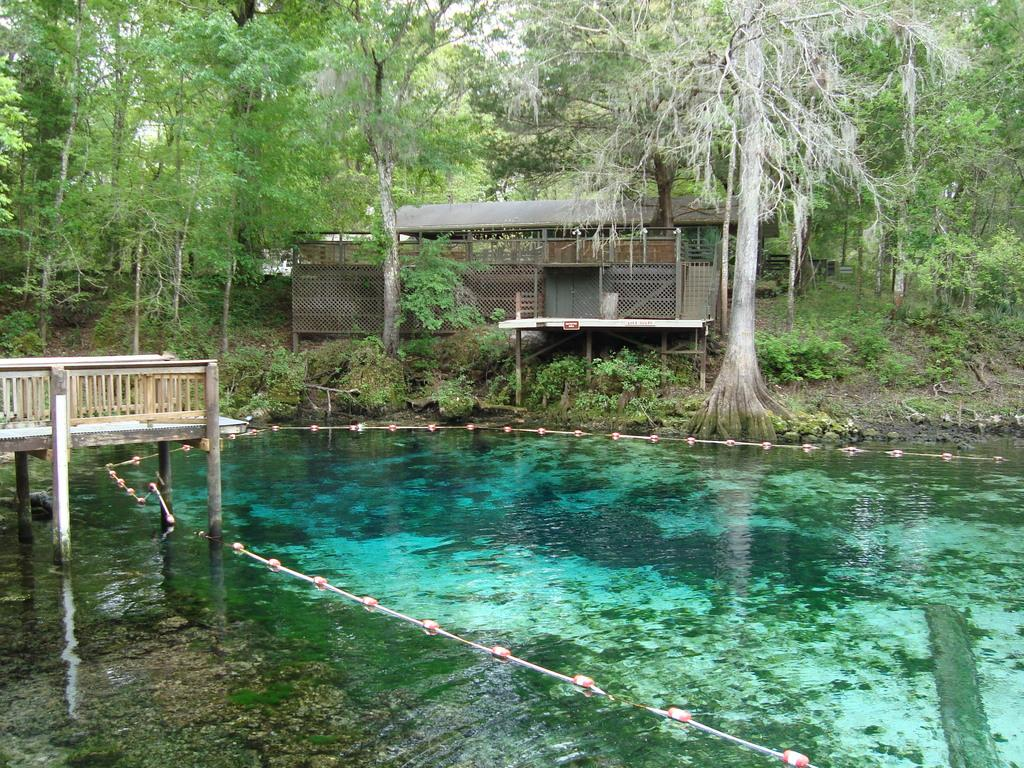What can be seen in the image that is related to a natural environment? There are trees visible in the image. What type of structure can be seen in the image? There is a house in the image. What is the primary element visible in the image? Water is visible in the image. Who is the owner of the tiger in the image? There is no tiger present in the image. What type of business is being conducted in the image? The image does not depict any business activities. 